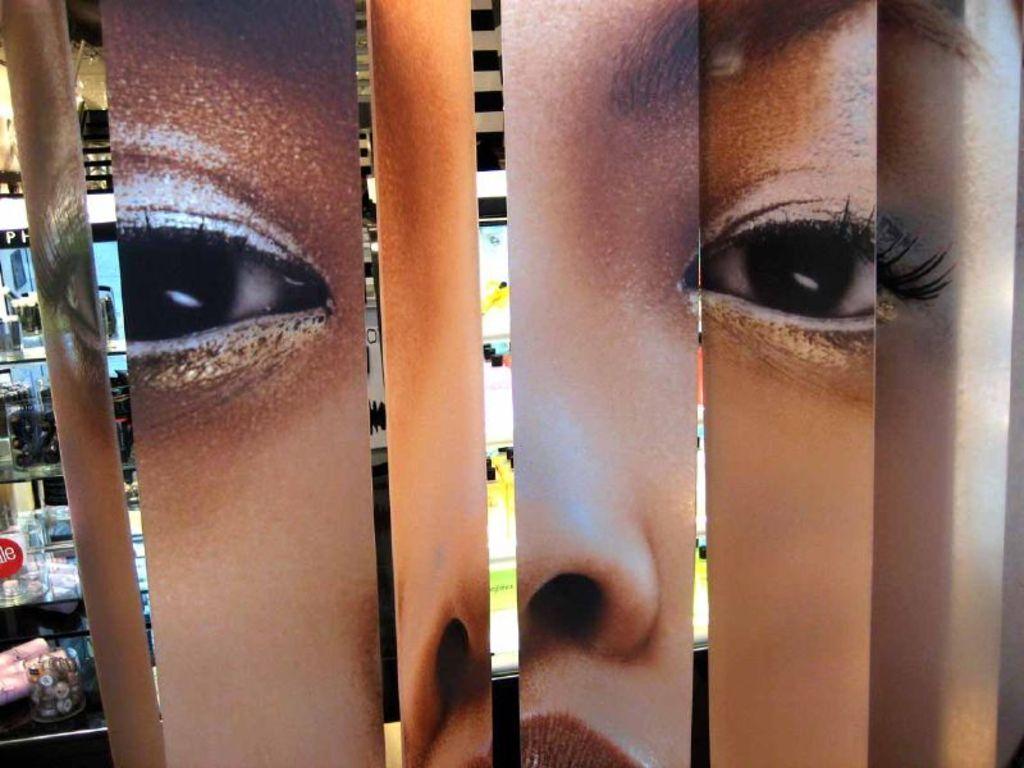Could you give a brief overview of what you see in this image? This is an edited image of the person's face and the background looks like the shelves with some objects on it. 